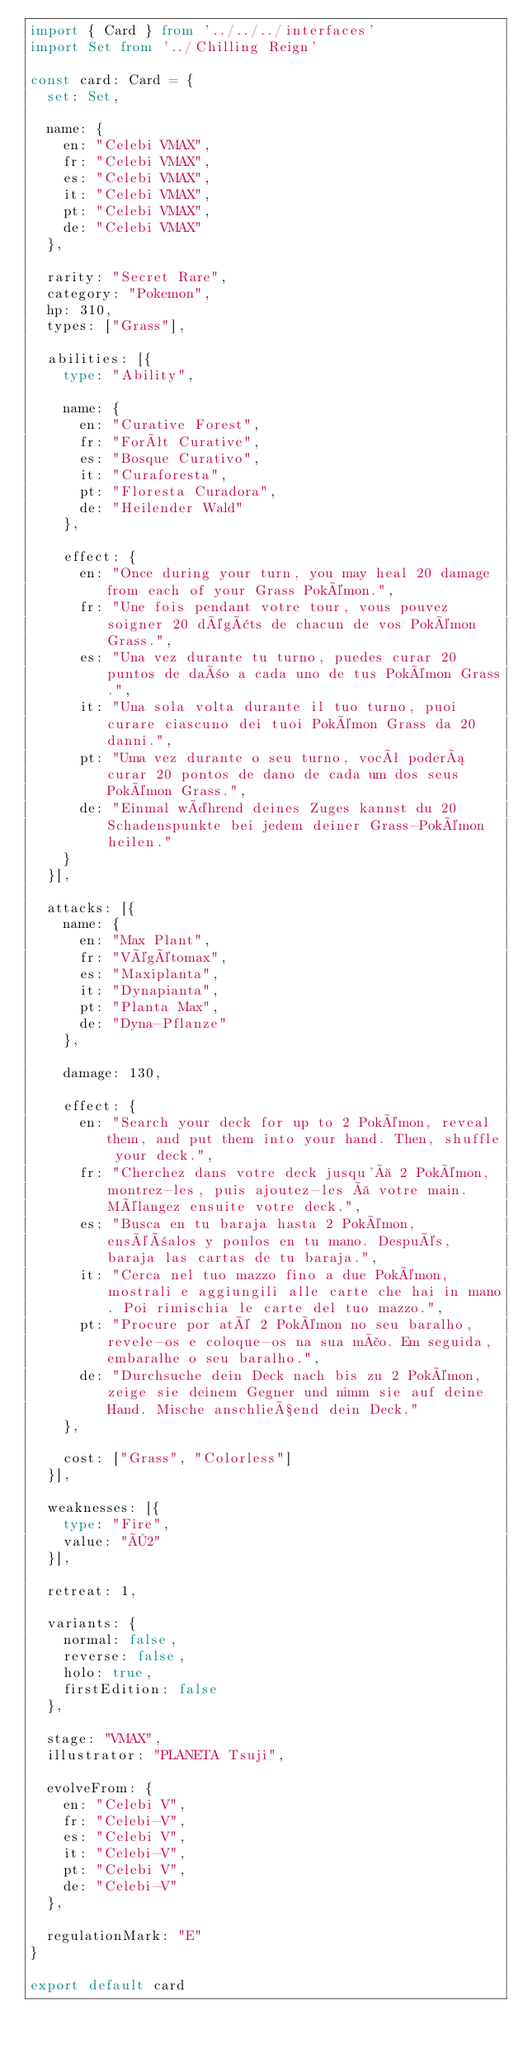Convert code to text. <code><loc_0><loc_0><loc_500><loc_500><_TypeScript_>import { Card } from '../../../interfaces'
import Set from '../Chilling Reign'

const card: Card = {
	set: Set,

	name: {
		en: "Celebi VMAX",
		fr: "Celebi VMAX",
		es: "Celebi VMAX",
		it: "Celebi VMAX",
		pt: "Celebi VMAX",
		de: "Celebi VMAX"
	},

	rarity: "Secret Rare",
	category: "Pokemon",
	hp: 310,
	types: ["Grass"],

	abilities: [{
		type: "Ability",

		name: {
			en: "Curative Forest",
			fr: "Forêt Curative",
			es: "Bosque Curativo",
			it: "Curaforesta",
			pt: "Floresta Curadora",
			de: "Heilender Wald"
		},

		effect: {
			en: "Once during your turn, you may heal 20 damage from each of your Grass Pokémon.",
			fr: "Une fois pendant votre tour, vous pouvez soigner 20 dégâts de chacun de vos Pokémon Grass.",
			es: "Una vez durante tu turno, puedes curar 20 puntos de daño a cada uno de tus Pokémon Grass.",
			it: "Una sola volta durante il tuo turno, puoi curare ciascuno dei tuoi Pokémon Grass da 20 danni.",
			pt: "Uma vez durante o seu turno, você poderá curar 20 pontos de dano de cada um dos seus Pokémon Grass.",
			de: "Einmal während deines Zuges kannst du 20 Schadenspunkte bei jedem deiner Grass-Pokémon heilen."
		}
	}],

	attacks: [{
		name: {
			en: "Max Plant",
			fr: "Végétomax",
			es: "Maxiplanta",
			it: "Dynapianta",
			pt: "Planta Max",
			de: "Dyna-Pflanze"
		},

		damage: 130,

		effect: {
			en: "Search your deck for up to 2 Pokémon, reveal them, and put them into your hand. Then, shuffle your deck.",
			fr: "Cherchez dans votre deck jusqu'à 2 Pokémon, montrez-les, puis ajoutez-les à votre main. Mélangez ensuite votre deck.",
			es: "Busca en tu baraja hasta 2 Pokémon, enséñalos y ponlos en tu mano. Después, baraja las cartas de tu baraja.",
			it: "Cerca nel tuo mazzo fino a due Pokémon, mostrali e aggiungili alle carte che hai in mano. Poi rimischia le carte del tuo mazzo.",
			pt: "Procure por até 2 Pokémon no seu baralho, revele-os e coloque-os na sua mão. Em seguida, embaralhe o seu baralho.",
			de: "Durchsuche dein Deck nach bis zu 2 Pokémon, zeige sie deinem Gegner und nimm sie auf deine Hand. Mische anschließend dein Deck."
		},

		cost: ["Grass", "Colorless"]
	}],

	weaknesses: [{
		type: "Fire",
		value: "×2"
	}],

	retreat: 1,

	variants: {
		normal: false,
		reverse: false,
		holo: true,
		firstEdition: false
	},

	stage: "VMAX",
	illustrator: "PLANETA Tsuji",

	evolveFrom: {
		en: "Celebi V",
		fr: "Celebi-V",
		es: "Celebi V",
		it: "Celebi-V",
		pt: "Celebi V",
		de: "Celebi-V"
	},

	regulationMark: "E"
}

export default card
</code> 